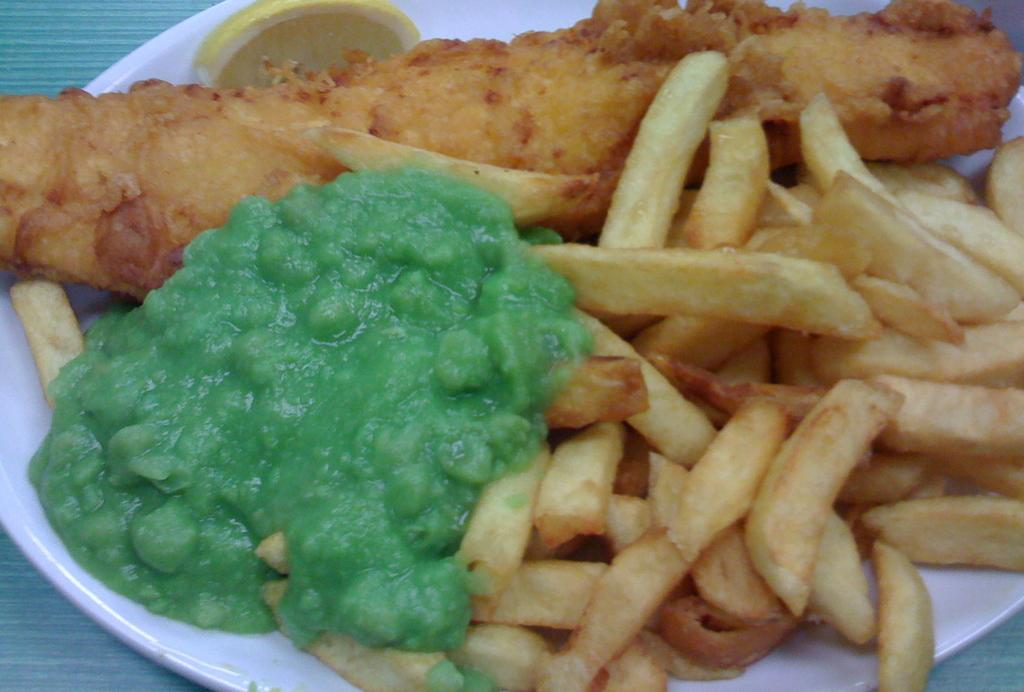What is on the plate in the image? There are food items on a plate in the image. What color is the plate? The plate is white. Where is the plate located in the image? The plate is placed on a surface. What type of building can be seen in the background of the image? There is no building visible in the image; it only shows a plate with food items on a surface. 